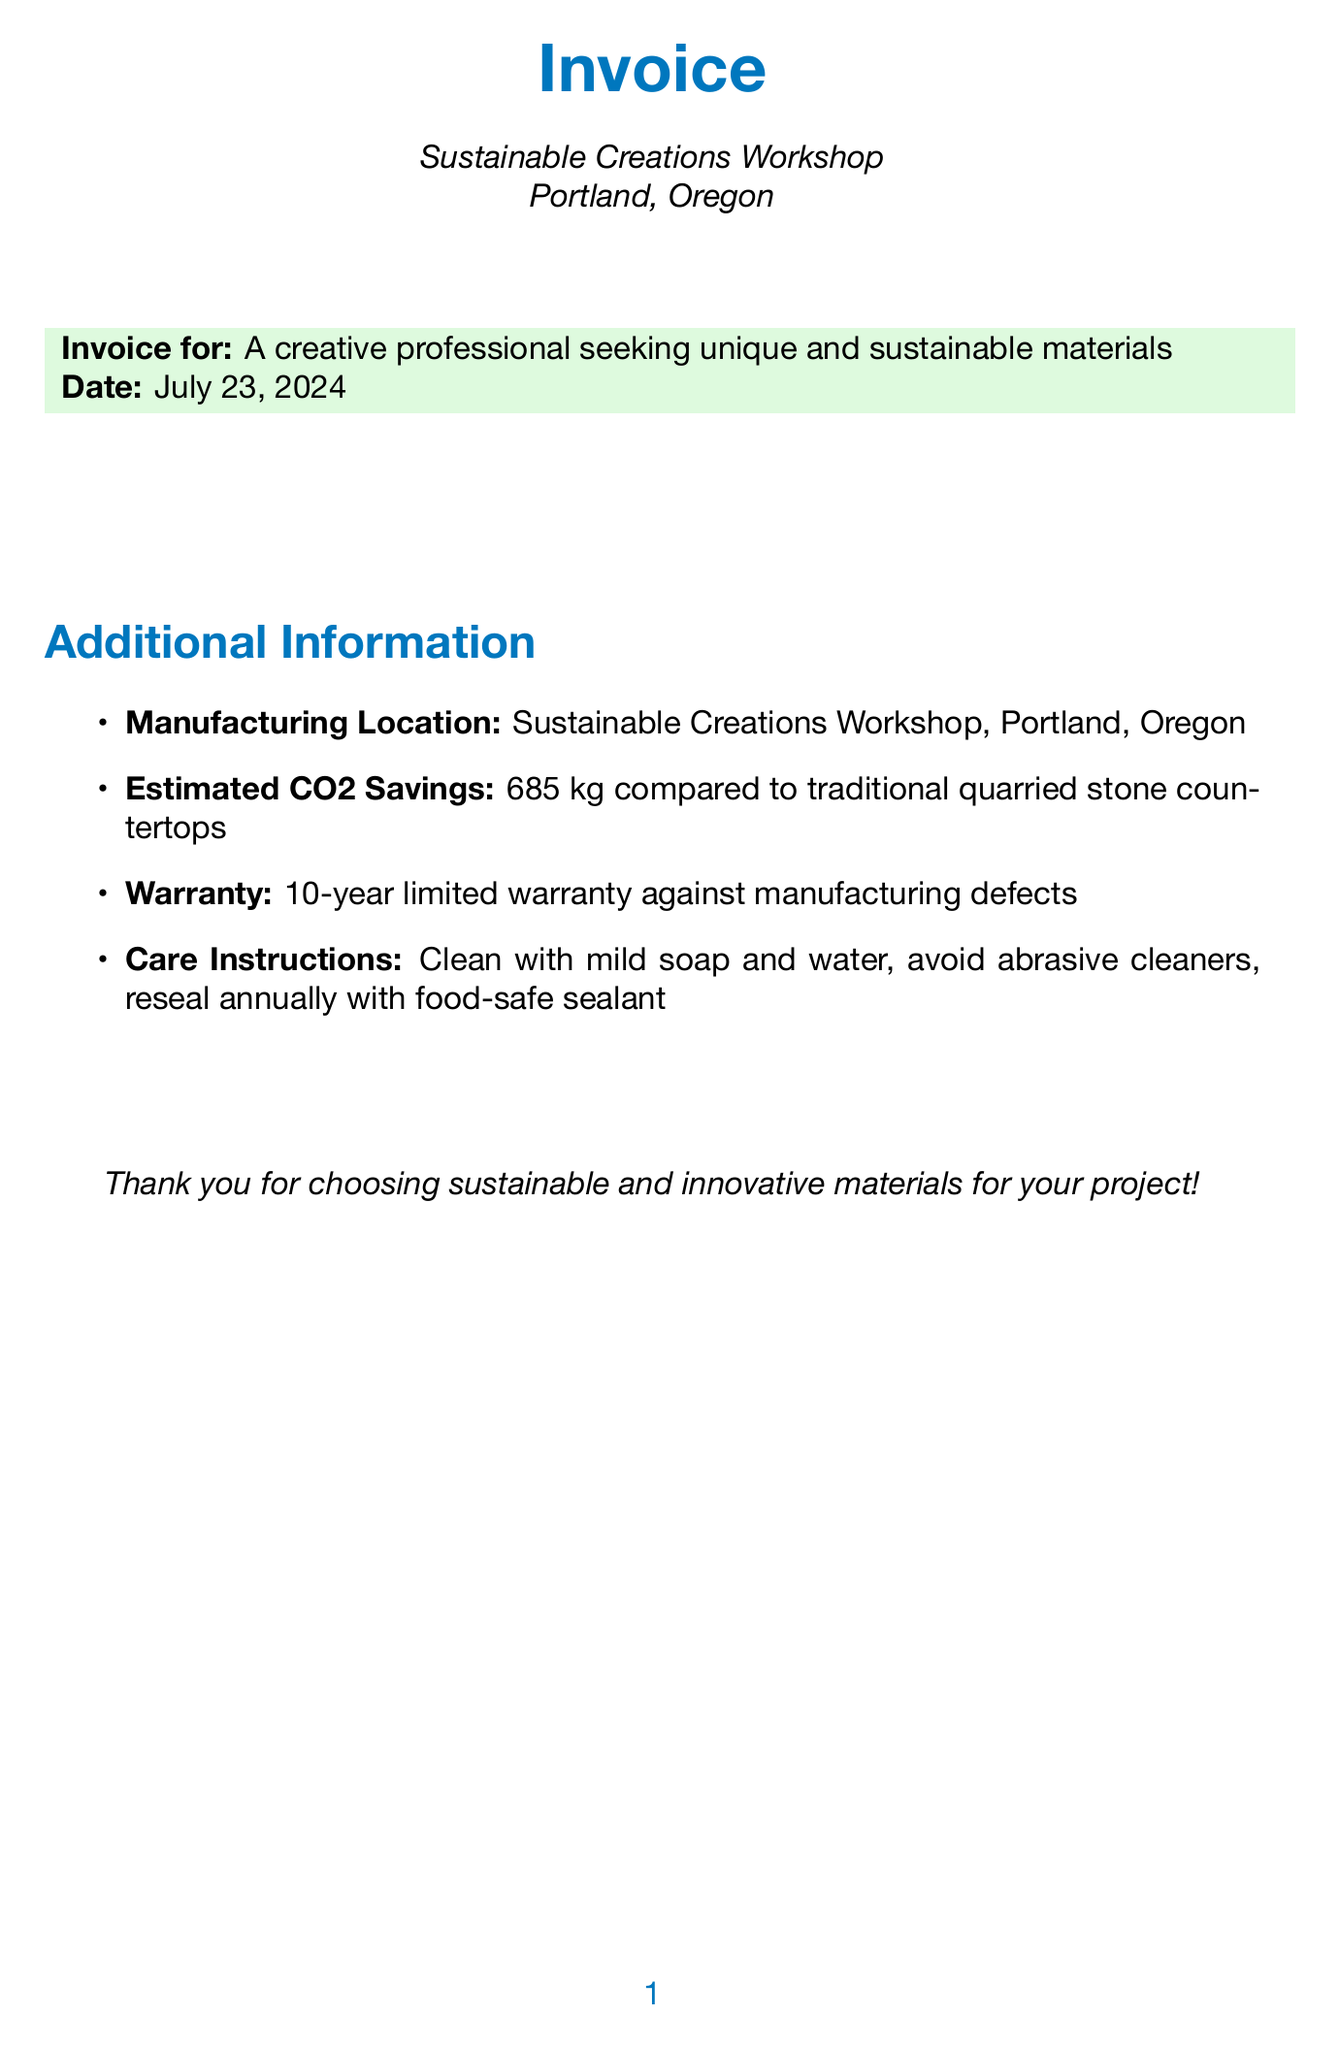What is the item name of the main product? The document lists "Custom Recycled Glass Countertop - Ocean Blue" as the main product.
Answer: Custom Recycled Glass Countertop - Ocean Blue What is the total amount of the invoice? The total amount is the sum of all items listed, which totals $8,305.00.
Answer: $8,305.00 How many units of the Eco-friendly Binding Resin were ordered? The invoice specifies a quantity of 5 for Eco-friendly Binding Resin.
Answer: 5 What type of resin is applied to the countertop? The document states that AEROMARINE PRODUCTS 300/21 Ultra Clear Epoxy Resin is used, which is low-VOC and environmentally friendly.
Answer: AEROMARINE PRODUCTS 300/21 Ultra Clear Epoxy Resin What is the estimated CO2 savings compared to traditional countertops? The document mentions an estimated CO2 savings of 685 kg compared to traditional quarried stone countertops.
Answer: 685 kg What process is used for polishing the countertop? The invoice describes a multi-stage polishing process using diamond-embedded pads from 50 to 3000 grit.
Answer: Multi-stage polishing process What is included in the sustainability consultation? The invoice notes expert consultation on maximizing eco-friendly aspects, including material sourcing and process optimization.
Answer: Material sourcing and process optimization How long is the warranty for the countertop? The warranty provided for the countertop is a 10-year limited warranty against manufacturing defects.
Answer: 10-year limited warranty 